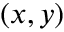Convert formula to latex. <formula><loc_0><loc_0><loc_500><loc_500>( x , y )</formula> 